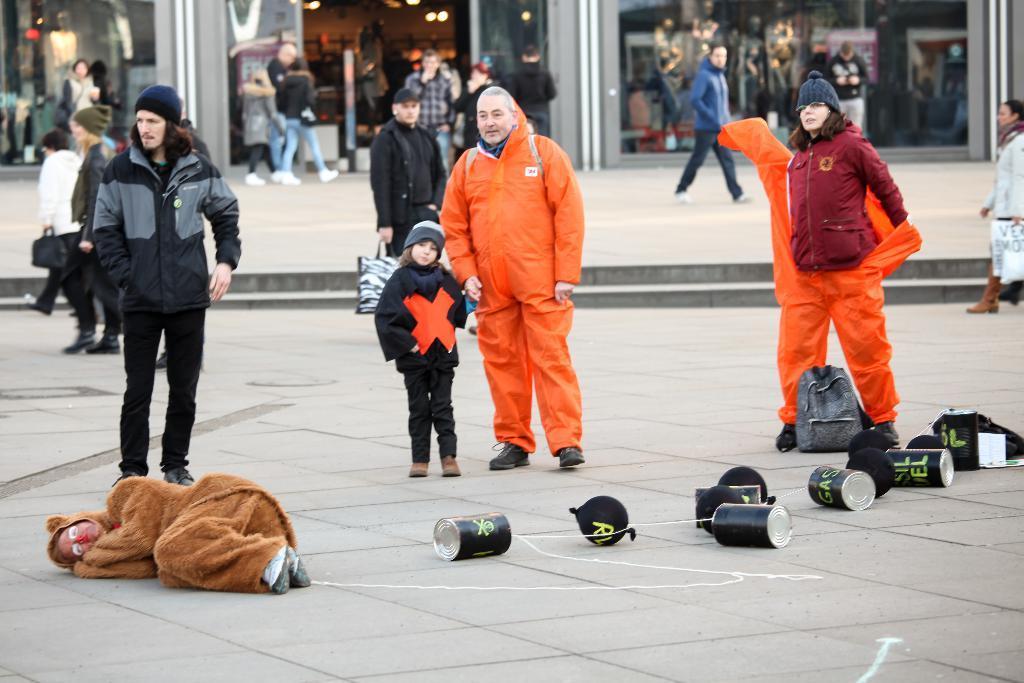In one or two sentences, can you explain what this image depicts? In this picture I can see there are three people standing here and they are wearing orange color raincoats and in the backdrop there is a shop and there is a door. 